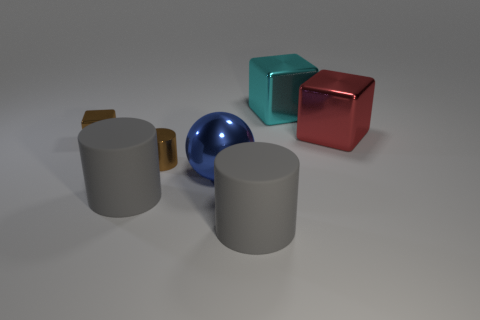There is a cube left of the big gray thing right of the blue sphere; how big is it?
Ensure brevity in your answer.  Small. Are there fewer big red metal objects right of the sphere than brown metallic cylinders behind the cyan metal thing?
Provide a succinct answer. No. Do the small metallic thing behind the small brown cylinder and the object behind the red object have the same color?
Your answer should be compact. No. The big thing that is in front of the large blue metal object and right of the large metal ball is made of what material?
Offer a very short reply. Rubber. Is there a cyan metallic thing?
Your answer should be very brief. Yes. There is a big blue object that is the same material as the brown cube; what is its shape?
Ensure brevity in your answer.  Sphere. Do the cyan object and the brown thing in front of the small brown cube have the same shape?
Provide a short and direct response. No. What material is the object left of the cylinder on the left side of the brown metallic cylinder?
Ensure brevity in your answer.  Metal. What number of other things are the same shape as the big red shiny thing?
Your answer should be compact. 2. There is a red shiny object behind the blue shiny thing; is its shape the same as the large gray object right of the blue sphere?
Keep it short and to the point. No. 